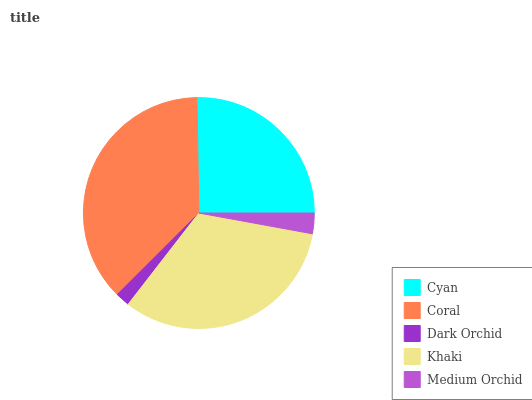Is Dark Orchid the minimum?
Answer yes or no. Yes. Is Coral the maximum?
Answer yes or no. Yes. Is Coral the minimum?
Answer yes or no. No. Is Dark Orchid the maximum?
Answer yes or no. No. Is Coral greater than Dark Orchid?
Answer yes or no. Yes. Is Dark Orchid less than Coral?
Answer yes or no. Yes. Is Dark Orchid greater than Coral?
Answer yes or no. No. Is Coral less than Dark Orchid?
Answer yes or no. No. Is Cyan the high median?
Answer yes or no. Yes. Is Cyan the low median?
Answer yes or no. Yes. Is Medium Orchid the high median?
Answer yes or no. No. Is Coral the low median?
Answer yes or no. No. 